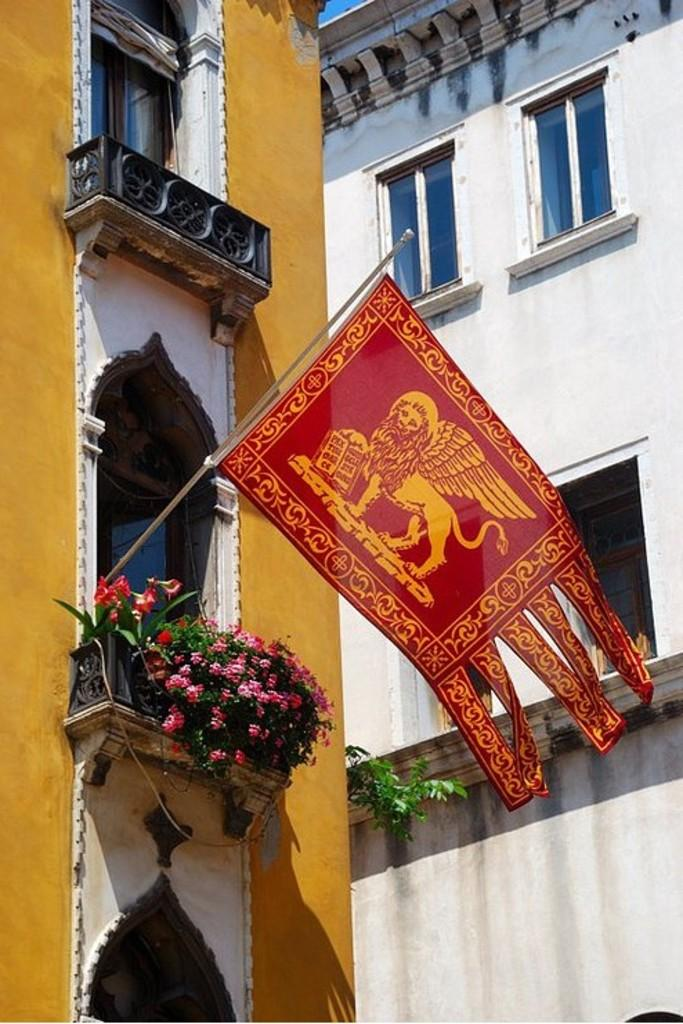What type of structures are visible in the image? There are buildings in the image. Can you describe any specific features of the buildings? One building has an attached flag. Are there any other objects or elements present in the image? Yes, there are potted plants in the image. What type of brass instrument can be seen in the image? There is no brass instrument present in the image. Can you describe the contents of the jar in the image? There is no jar present in the image. 